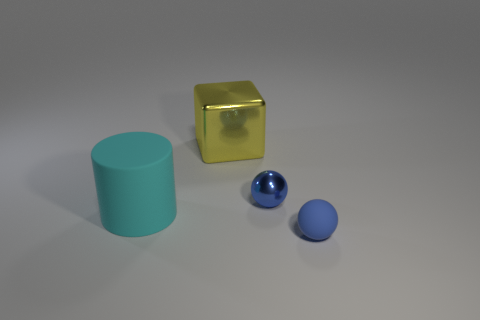Add 3 blocks. How many objects exist? 7 Subtract all cylinders. How many objects are left? 3 Add 2 blue matte objects. How many blue matte objects exist? 3 Subtract 0 red cubes. How many objects are left? 4 Subtract all big red shiny balls. Subtract all cyan rubber objects. How many objects are left? 3 Add 4 big objects. How many big objects are left? 6 